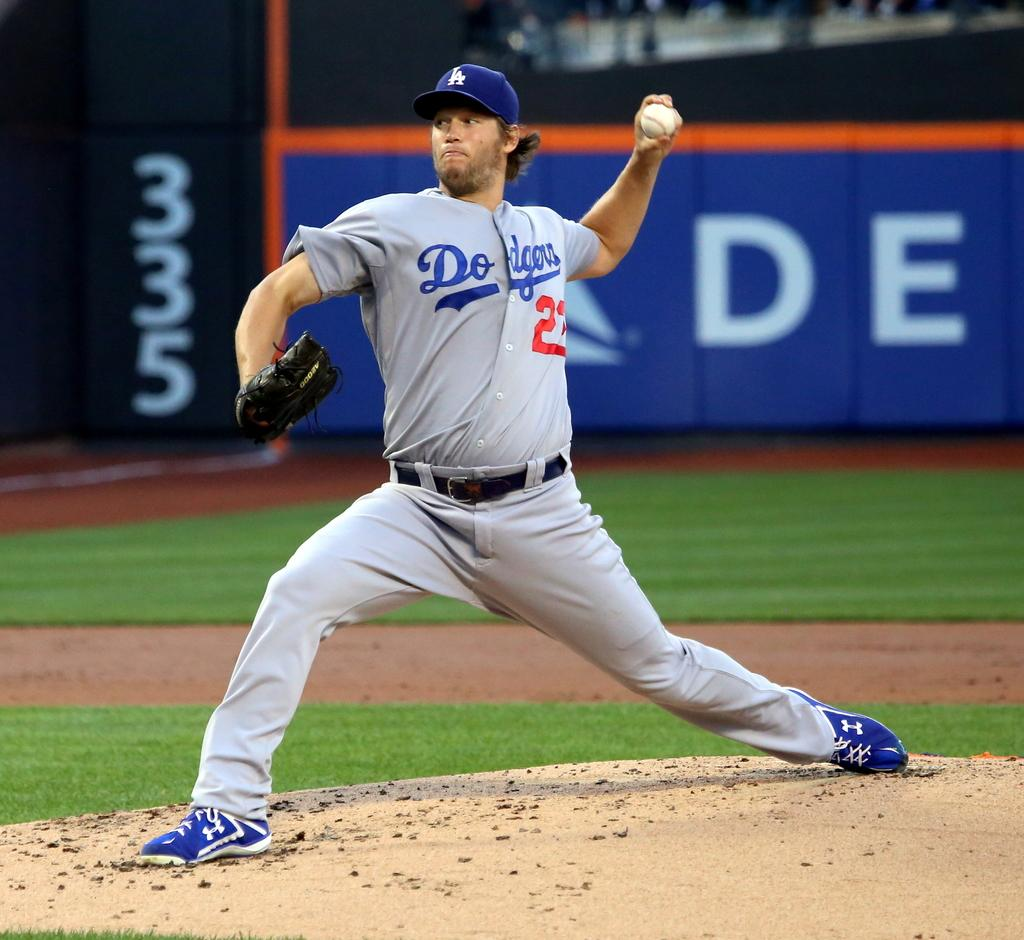<image>
Relay a brief, clear account of the picture shown. a player with the name Dodgers on his jersey 